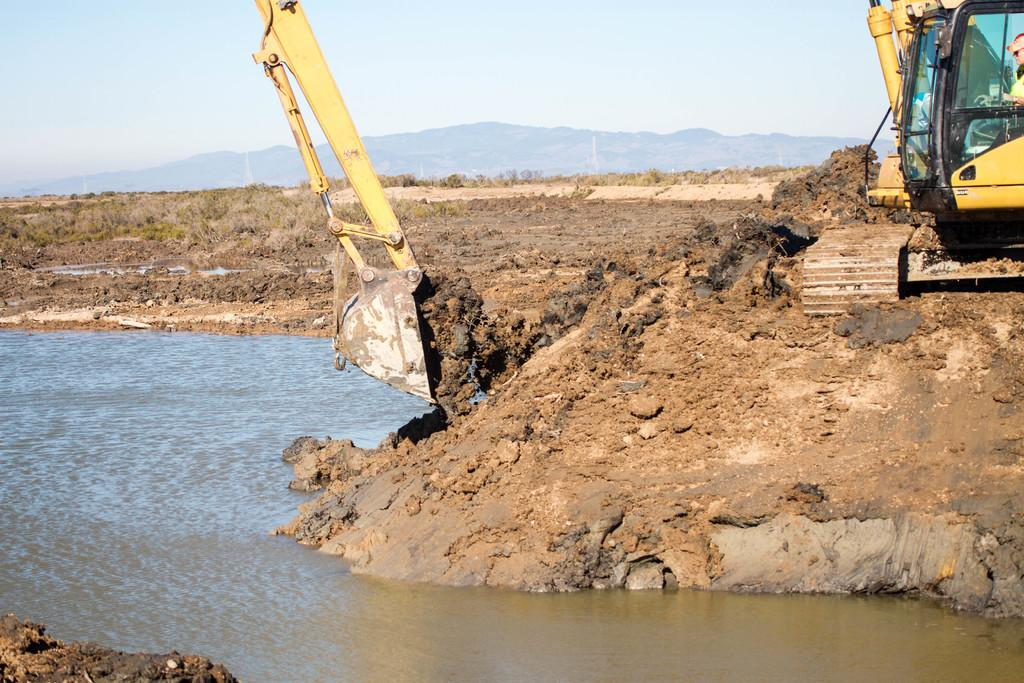What is located at the bottom of the image? There is a lake at the bottom of the image. What activity is taking place on the right side of the image? There is a crane excavating on the right side of the image. What can be seen in the background of the image? There is a hill and the sky visible in the background of the image. Can you see a boy playing with a fowl near the lake in the image? There is no boy or fowl present in the image; it features a lake, a crane excavating, a hill, and the sky. Is the lake hot in the image? The temperature of the lake is not mentioned in the image, but the presence of water suggests it is not hot. 